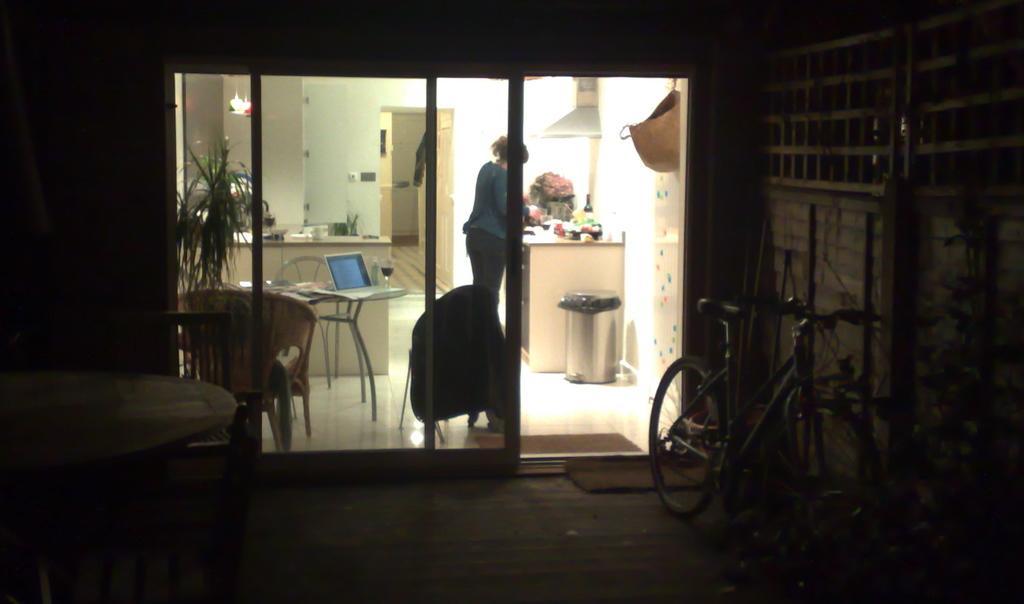Describe this image in one or two sentences. a woman is standing at a counter and doing something. There is laptop and wine glass on a table. There is a cycle beside the door of the room. 